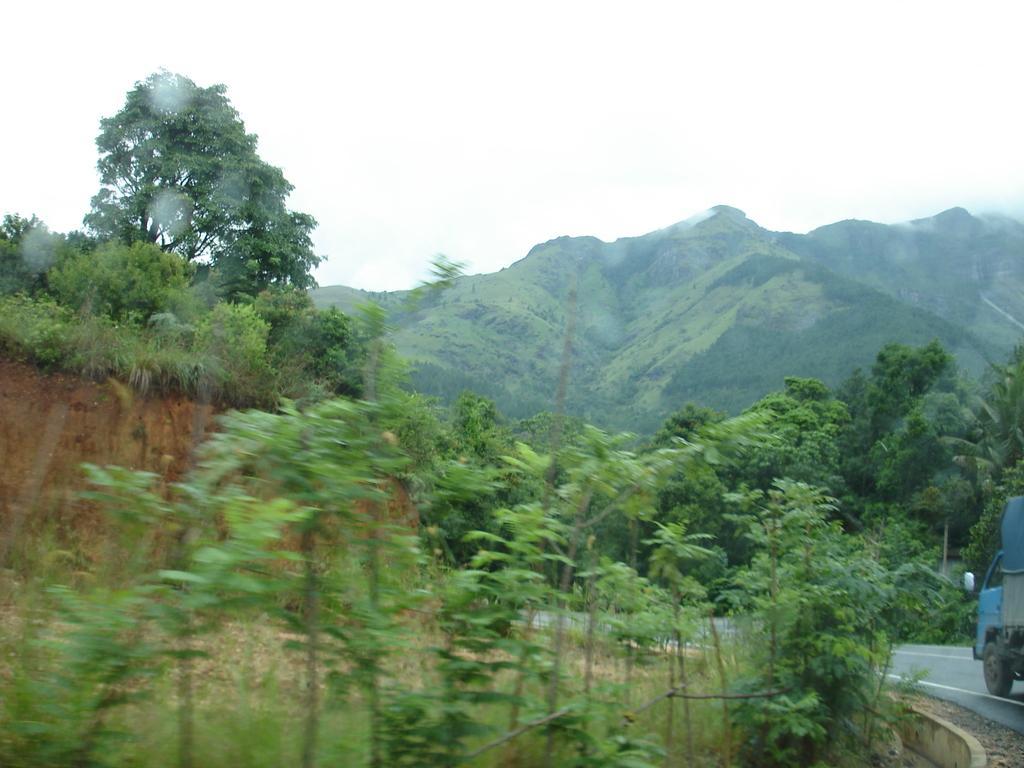Could you give a brief overview of what you see in this image? In the foreground of this image, there are trees. On the right, there is a vehicle moving on the road. In the background, there are trees, mountains and the sky. 